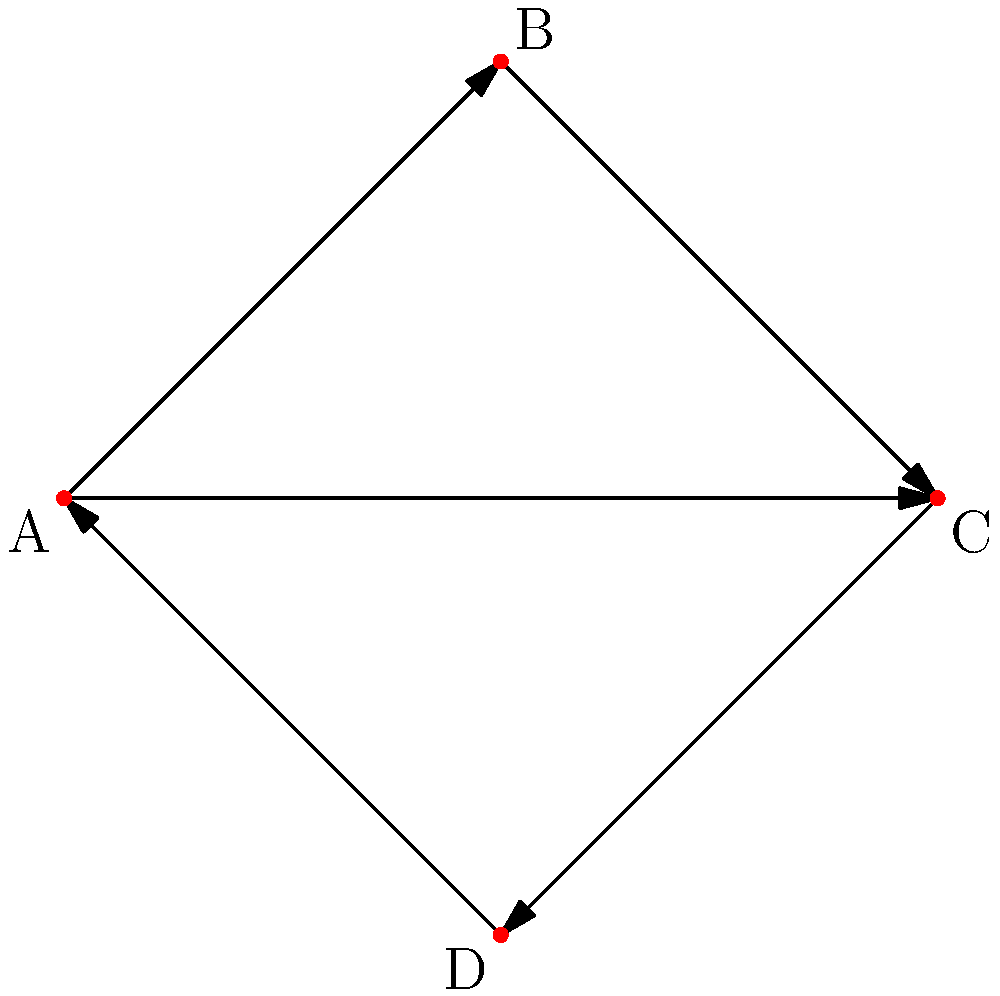In your social media follower network, represented as a directed graph, you notice a cyclic pattern. Given the graph above, what is the size of the largest strongly connected component, and how might this impact your band's online promotion strategy? To solve this problem, we need to follow these steps:

1. Understand the concept of a strongly connected component (SCC):
   An SCC is a subgraph where every vertex is reachable from every other vertex.

2. Identify the strongly connected components in the given graph:
   - A → B → C → D → A forms a cycle, meaning all these vertices are mutually reachable.
   - There's an additional edge from A to C, but it doesn't change the SCC structure.

3. Count the number of vertices in the largest SCC:
   The entire graph forms one SCC, containing all 4 vertices (A, B, C, and D).

4. Interpret the result for social media strategy:
   - A strongly connected component of size 4 indicates a tight-knit community where information can flow freely between all members.
   - This structure suggests that content shared by the band has the potential to reach all followers through various paths, increasing engagement and virality.
   - The cyclic nature implies that followers are interconnected, which can amplify the band's message through multiple sharing and resharing.
   - The DIY approach can leverage this network structure by creating content that encourages interaction between followers, as the information is likely to circulate within the strongly connected component.

5. Consider the implications for internet promotion:
   - Focus on engaging all members of this strongly connected component, as each follower has the potential to influence the entire network.
   - Create content that encourages sharing and interaction to take advantage of the cyclic structure.
   - Use targeted promotions that can quickly spread through the entire component due to its strong connectivity.
Answer: 4; leverage cyclic structure for viral content 